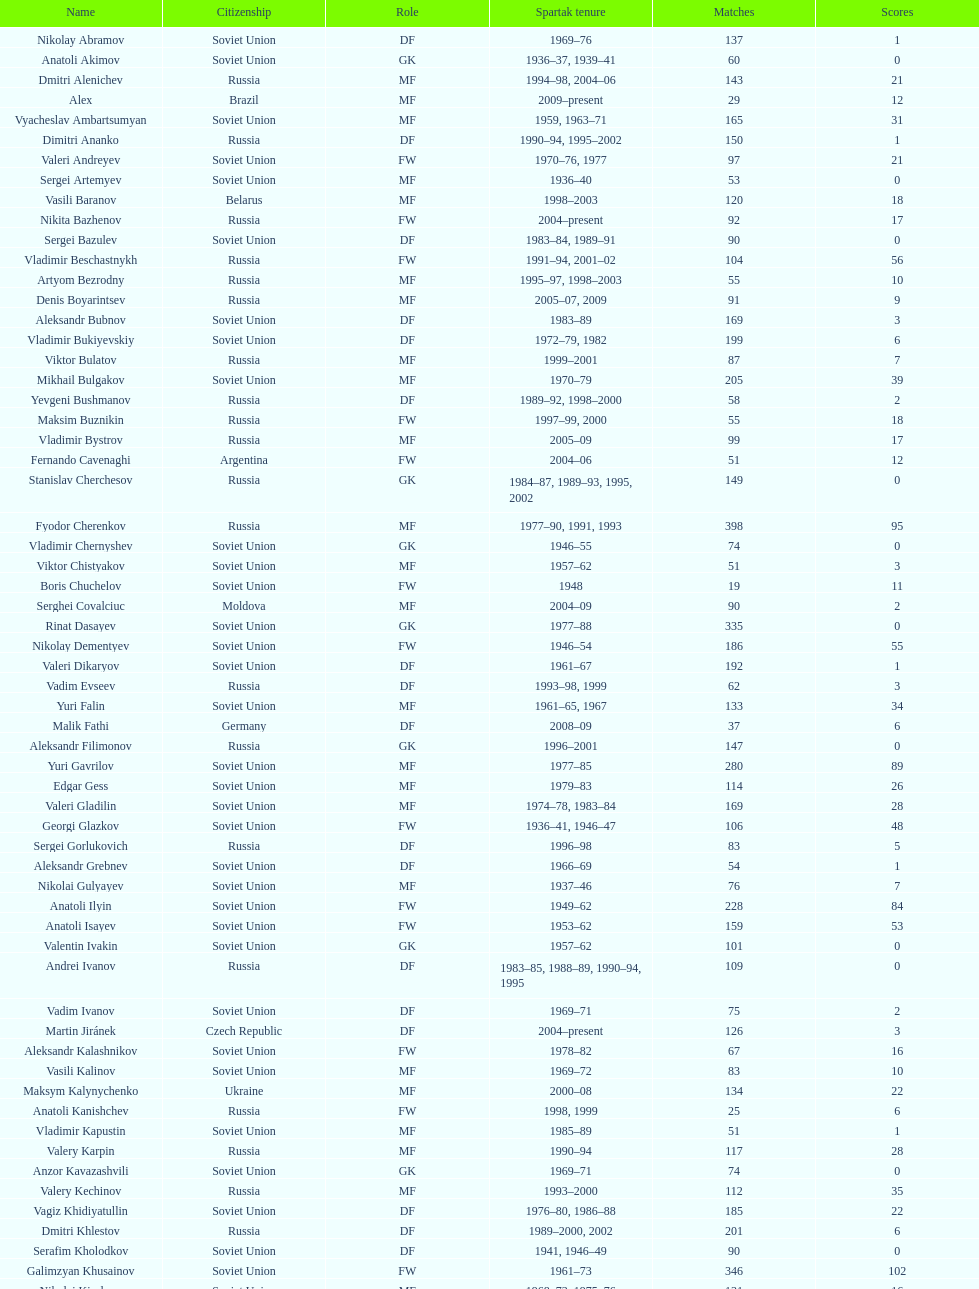Baranov has played from 2004 to the present. what is his nationality? Belarus. 